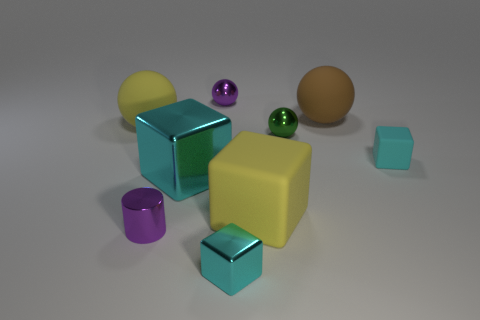How many big rubber things are behind the small cyan cube that is on the right side of the big yellow rubber thing right of the big cyan metallic cube?
Make the answer very short. 2. Are there any cylinders to the left of the tiny matte object?
Your answer should be very brief. Yes. How many cylinders are big brown objects or large objects?
Your response must be concise. 0. How many spheres are behind the green shiny sphere and on the right side of the yellow sphere?
Your answer should be compact. 2. Is the number of large cyan things on the left side of the small purple shiny cylinder the same as the number of large yellow spheres that are in front of the small cyan matte object?
Give a very brief answer. Yes. There is a big yellow thing that is left of the purple sphere; does it have the same shape as the big brown thing?
Keep it short and to the point. Yes. There is a tiny purple object that is behind the block that is to the right of the sphere that is in front of the yellow rubber sphere; what shape is it?
Provide a succinct answer. Sphere. There is a large rubber object that is the same color as the big rubber block; what is its shape?
Your answer should be very brief. Sphere. There is a small thing that is behind the small cyan matte block and to the left of the tiny green thing; what material is it?
Provide a succinct answer. Metal. Is the number of large matte spheres less than the number of small metal cubes?
Keep it short and to the point. No. 